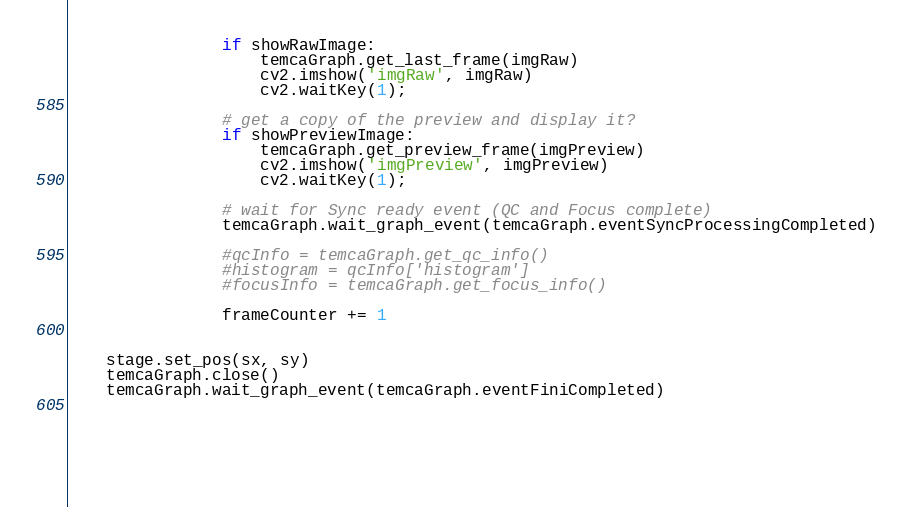<code> <loc_0><loc_0><loc_500><loc_500><_Python_>                if showRawImage:
                    temcaGraph.get_last_frame(imgRaw)
                    cv2.imshow('imgRaw', imgRaw)
                    cv2.waitKey(1);

                # get a copy of the preview and display it?
                if showPreviewImage:
                    temcaGraph.get_preview_frame(imgPreview)
                    cv2.imshow('imgPreview', imgPreview)
                    cv2.waitKey(1);

                # wait for Sync ready event (QC and Focus complete)
                temcaGraph.wait_graph_event(temcaGraph.eventSyncProcessingCompleted)

                #qcInfo = temcaGraph.get_qc_info()
                #histogram = qcInfo['histogram']
                #focusInfo = temcaGraph.get_focus_info()

                frameCounter += 1


    stage.set_pos(sx, sy)
    temcaGraph.close()
    temcaGraph.wait_graph_event(temcaGraph.eventFiniCompleted)
    



 
</code> 